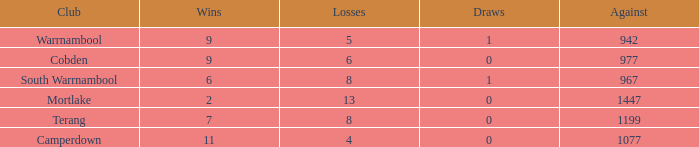How many draws did Mortlake have when the losses were more than 5? 1.0. 